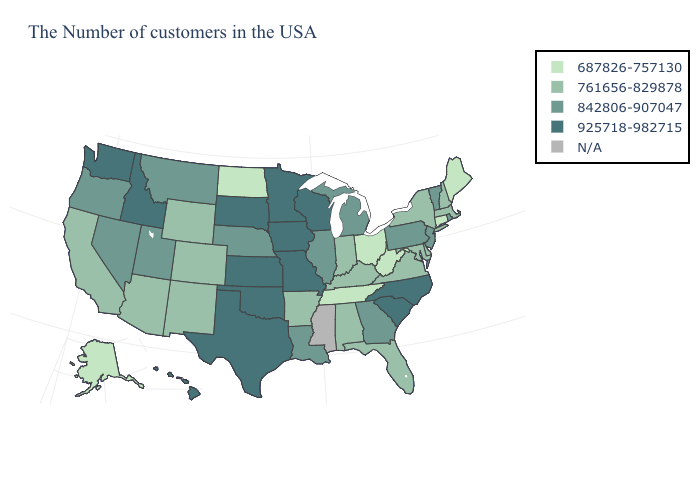What is the value of Maine?
Keep it brief. 687826-757130. What is the value of Illinois?
Quick response, please. 842806-907047. Among the states that border Georgia , which have the lowest value?
Write a very short answer. Tennessee. Among the states that border Nevada , which have the highest value?
Give a very brief answer. Idaho. What is the value of Florida?
Short answer required. 761656-829878. Does the map have missing data?
Be succinct. Yes. What is the highest value in states that border New Mexico?
Answer briefly. 925718-982715. Which states have the lowest value in the MidWest?
Give a very brief answer. Ohio, North Dakota. What is the value of Wyoming?
Answer briefly. 761656-829878. Among the states that border South Carolina , does North Carolina have the lowest value?
Concise answer only. No. What is the lowest value in states that border Virginia?
Keep it brief. 687826-757130. What is the value of Nevada?
Answer briefly. 842806-907047. Which states have the lowest value in the MidWest?
Short answer required. Ohio, North Dakota. What is the value of Wyoming?
Short answer required. 761656-829878. Does the first symbol in the legend represent the smallest category?
Be succinct. Yes. 